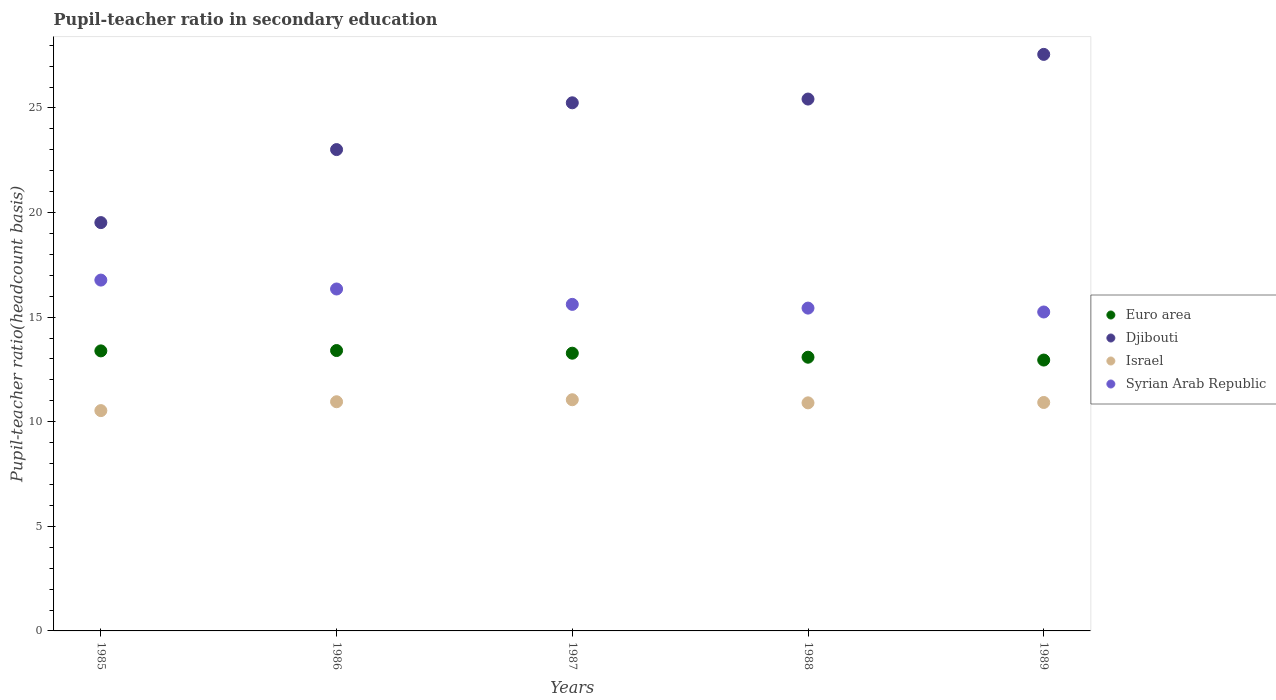How many different coloured dotlines are there?
Your answer should be very brief. 4. What is the pupil-teacher ratio in secondary education in Israel in 1988?
Your answer should be compact. 10.9. Across all years, what is the maximum pupil-teacher ratio in secondary education in Djibouti?
Ensure brevity in your answer.  27.56. Across all years, what is the minimum pupil-teacher ratio in secondary education in Syrian Arab Republic?
Offer a terse response. 15.25. In which year was the pupil-teacher ratio in secondary education in Djibouti maximum?
Your response must be concise. 1989. What is the total pupil-teacher ratio in secondary education in Israel in the graph?
Offer a very short reply. 54.36. What is the difference between the pupil-teacher ratio in secondary education in Israel in 1986 and that in 1989?
Offer a terse response. 0.03. What is the difference between the pupil-teacher ratio in secondary education in Syrian Arab Republic in 1988 and the pupil-teacher ratio in secondary education in Euro area in 1989?
Provide a succinct answer. 2.48. What is the average pupil-teacher ratio in secondary education in Euro area per year?
Keep it short and to the point. 13.22. In the year 1987, what is the difference between the pupil-teacher ratio in secondary education in Israel and pupil-teacher ratio in secondary education in Euro area?
Provide a short and direct response. -2.22. In how many years, is the pupil-teacher ratio in secondary education in Euro area greater than 20?
Give a very brief answer. 0. What is the ratio of the pupil-teacher ratio in secondary education in Israel in 1985 to that in 1988?
Your response must be concise. 0.97. What is the difference between the highest and the second highest pupil-teacher ratio in secondary education in Israel?
Your answer should be compact. 0.1. What is the difference between the highest and the lowest pupil-teacher ratio in secondary education in Djibouti?
Make the answer very short. 8.04. Is the sum of the pupil-teacher ratio in secondary education in Djibouti in 1985 and 1988 greater than the maximum pupil-teacher ratio in secondary education in Israel across all years?
Provide a short and direct response. Yes. Is it the case that in every year, the sum of the pupil-teacher ratio in secondary education in Israel and pupil-teacher ratio in secondary education in Syrian Arab Republic  is greater than the sum of pupil-teacher ratio in secondary education in Euro area and pupil-teacher ratio in secondary education in Djibouti?
Provide a succinct answer. No. Is it the case that in every year, the sum of the pupil-teacher ratio in secondary education in Euro area and pupil-teacher ratio in secondary education in Djibouti  is greater than the pupil-teacher ratio in secondary education in Syrian Arab Republic?
Keep it short and to the point. Yes. Does the pupil-teacher ratio in secondary education in Djibouti monotonically increase over the years?
Provide a short and direct response. Yes. Is the pupil-teacher ratio in secondary education in Syrian Arab Republic strictly greater than the pupil-teacher ratio in secondary education in Euro area over the years?
Give a very brief answer. Yes. Is the pupil-teacher ratio in secondary education in Djibouti strictly less than the pupil-teacher ratio in secondary education in Euro area over the years?
Give a very brief answer. No. How many years are there in the graph?
Ensure brevity in your answer.  5. Are the values on the major ticks of Y-axis written in scientific E-notation?
Keep it short and to the point. No. Does the graph contain any zero values?
Your answer should be very brief. No. Does the graph contain grids?
Make the answer very short. No. Where does the legend appear in the graph?
Offer a terse response. Center right. How many legend labels are there?
Give a very brief answer. 4. What is the title of the graph?
Your answer should be compact. Pupil-teacher ratio in secondary education. What is the label or title of the X-axis?
Your answer should be very brief. Years. What is the label or title of the Y-axis?
Your response must be concise. Pupil-teacher ratio(headcount basis). What is the Pupil-teacher ratio(headcount basis) in Euro area in 1985?
Offer a very short reply. 13.39. What is the Pupil-teacher ratio(headcount basis) of Djibouti in 1985?
Offer a very short reply. 19.52. What is the Pupil-teacher ratio(headcount basis) of Israel in 1985?
Provide a succinct answer. 10.53. What is the Pupil-teacher ratio(headcount basis) in Syrian Arab Republic in 1985?
Your answer should be compact. 16.77. What is the Pupil-teacher ratio(headcount basis) of Euro area in 1986?
Ensure brevity in your answer.  13.4. What is the Pupil-teacher ratio(headcount basis) in Djibouti in 1986?
Offer a terse response. 23.01. What is the Pupil-teacher ratio(headcount basis) in Israel in 1986?
Offer a very short reply. 10.96. What is the Pupil-teacher ratio(headcount basis) of Syrian Arab Republic in 1986?
Your answer should be very brief. 16.35. What is the Pupil-teacher ratio(headcount basis) of Euro area in 1987?
Provide a succinct answer. 13.28. What is the Pupil-teacher ratio(headcount basis) of Djibouti in 1987?
Make the answer very short. 25.25. What is the Pupil-teacher ratio(headcount basis) in Israel in 1987?
Keep it short and to the point. 11.05. What is the Pupil-teacher ratio(headcount basis) in Syrian Arab Republic in 1987?
Offer a very short reply. 15.61. What is the Pupil-teacher ratio(headcount basis) of Euro area in 1988?
Your answer should be compact. 13.08. What is the Pupil-teacher ratio(headcount basis) of Djibouti in 1988?
Keep it short and to the point. 25.43. What is the Pupil-teacher ratio(headcount basis) of Israel in 1988?
Offer a terse response. 10.9. What is the Pupil-teacher ratio(headcount basis) of Syrian Arab Republic in 1988?
Make the answer very short. 15.43. What is the Pupil-teacher ratio(headcount basis) of Euro area in 1989?
Offer a very short reply. 12.95. What is the Pupil-teacher ratio(headcount basis) in Djibouti in 1989?
Offer a terse response. 27.56. What is the Pupil-teacher ratio(headcount basis) of Israel in 1989?
Provide a short and direct response. 10.92. What is the Pupil-teacher ratio(headcount basis) of Syrian Arab Republic in 1989?
Offer a terse response. 15.25. Across all years, what is the maximum Pupil-teacher ratio(headcount basis) in Euro area?
Make the answer very short. 13.4. Across all years, what is the maximum Pupil-teacher ratio(headcount basis) of Djibouti?
Provide a short and direct response. 27.56. Across all years, what is the maximum Pupil-teacher ratio(headcount basis) of Israel?
Your answer should be very brief. 11.05. Across all years, what is the maximum Pupil-teacher ratio(headcount basis) of Syrian Arab Republic?
Make the answer very short. 16.77. Across all years, what is the minimum Pupil-teacher ratio(headcount basis) of Euro area?
Offer a very short reply. 12.95. Across all years, what is the minimum Pupil-teacher ratio(headcount basis) in Djibouti?
Offer a terse response. 19.52. Across all years, what is the minimum Pupil-teacher ratio(headcount basis) of Israel?
Give a very brief answer. 10.53. Across all years, what is the minimum Pupil-teacher ratio(headcount basis) in Syrian Arab Republic?
Ensure brevity in your answer.  15.25. What is the total Pupil-teacher ratio(headcount basis) of Euro area in the graph?
Your response must be concise. 66.1. What is the total Pupil-teacher ratio(headcount basis) of Djibouti in the graph?
Your answer should be compact. 120.76. What is the total Pupil-teacher ratio(headcount basis) in Israel in the graph?
Your answer should be very brief. 54.36. What is the total Pupil-teacher ratio(headcount basis) in Syrian Arab Republic in the graph?
Your answer should be compact. 79.4. What is the difference between the Pupil-teacher ratio(headcount basis) of Euro area in 1985 and that in 1986?
Ensure brevity in your answer.  -0.02. What is the difference between the Pupil-teacher ratio(headcount basis) in Djibouti in 1985 and that in 1986?
Provide a succinct answer. -3.49. What is the difference between the Pupil-teacher ratio(headcount basis) in Israel in 1985 and that in 1986?
Offer a terse response. -0.42. What is the difference between the Pupil-teacher ratio(headcount basis) in Syrian Arab Republic in 1985 and that in 1986?
Provide a succinct answer. 0.43. What is the difference between the Pupil-teacher ratio(headcount basis) in Euro area in 1985 and that in 1987?
Your answer should be very brief. 0.11. What is the difference between the Pupil-teacher ratio(headcount basis) in Djibouti in 1985 and that in 1987?
Make the answer very short. -5.73. What is the difference between the Pupil-teacher ratio(headcount basis) in Israel in 1985 and that in 1987?
Ensure brevity in your answer.  -0.52. What is the difference between the Pupil-teacher ratio(headcount basis) of Syrian Arab Republic in 1985 and that in 1987?
Give a very brief answer. 1.16. What is the difference between the Pupil-teacher ratio(headcount basis) in Euro area in 1985 and that in 1988?
Offer a terse response. 0.3. What is the difference between the Pupil-teacher ratio(headcount basis) in Djibouti in 1985 and that in 1988?
Make the answer very short. -5.91. What is the difference between the Pupil-teacher ratio(headcount basis) of Israel in 1985 and that in 1988?
Your response must be concise. -0.37. What is the difference between the Pupil-teacher ratio(headcount basis) in Syrian Arab Republic in 1985 and that in 1988?
Ensure brevity in your answer.  1.34. What is the difference between the Pupil-teacher ratio(headcount basis) in Euro area in 1985 and that in 1989?
Make the answer very short. 0.44. What is the difference between the Pupil-teacher ratio(headcount basis) of Djibouti in 1985 and that in 1989?
Your answer should be compact. -8.04. What is the difference between the Pupil-teacher ratio(headcount basis) in Israel in 1985 and that in 1989?
Provide a succinct answer. -0.39. What is the difference between the Pupil-teacher ratio(headcount basis) of Syrian Arab Republic in 1985 and that in 1989?
Provide a succinct answer. 1.53. What is the difference between the Pupil-teacher ratio(headcount basis) in Euro area in 1986 and that in 1987?
Give a very brief answer. 0.13. What is the difference between the Pupil-teacher ratio(headcount basis) of Djibouti in 1986 and that in 1987?
Give a very brief answer. -2.24. What is the difference between the Pupil-teacher ratio(headcount basis) in Israel in 1986 and that in 1987?
Offer a very short reply. -0.1. What is the difference between the Pupil-teacher ratio(headcount basis) in Syrian Arab Republic in 1986 and that in 1987?
Ensure brevity in your answer.  0.74. What is the difference between the Pupil-teacher ratio(headcount basis) of Euro area in 1986 and that in 1988?
Give a very brief answer. 0.32. What is the difference between the Pupil-teacher ratio(headcount basis) in Djibouti in 1986 and that in 1988?
Provide a succinct answer. -2.42. What is the difference between the Pupil-teacher ratio(headcount basis) of Israel in 1986 and that in 1988?
Provide a succinct answer. 0.05. What is the difference between the Pupil-teacher ratio(headcount basis) of Syrian Arab Republic in 1986 and that in 1988?
Provide a succinct answer. 0.91. What is the difference between the Pupil-teacher ratio(headcount basis) in Euro area in 1986 and that in 1989?
Your answer should be very brief. 0.45. What is the difference between the Pupil-teacher ratio(headcount basis) in Djibouti in 1986 and that in 1989?
Offer a terse response. -4.55. What is the difference between the Pupil-teacher ratio(headcount basis) of Israel in 1986 and that in 1989?
Make the answer very short. 0.03. What is the difference between the Pupil-teacher ratio(headcount basis) of Syrian Arab Republic in 1986 and that in 1989?
Ensure brevity in your answer.  1.1. What is the difference between the Pupil-teacher ratio(headcount basis) of Euro area in 1987 and that in 1988?
Offer a very short reply. 0.19. What is the difference between the Pupil-teacher ratio(headcount basis) of Djibouti in 1987 and that in 1988?
Give a very brief answer. -0.18. What is the difference between the Pupil-teacher ratio(headcount basis) in Israel in 1987 and that in 1988?
Your answer should be compact. 0.15. What is the difference between the Pupil-teacher ratio(headcount basis) of Syrian Arab Republic in 1987 and that in 1988?
Your response must be concise. 0.18. What is the difference between the Pupil-teacher ratio(headcount basis) in Euro area in 1987 and that in 1989?
Offer a very short reply. 0.33. What is the difference between the Pupil-teacher ratio(headcount basis) of Djibouti in 1987 and that in 1989?
Provide a succinct answer. -2.31. What is the difference between the Pupil-teacher ratio(headcount basis) in Israel in 1987 and that in 1989?
Your answer should be very brief. 0.13. What is the difference between the Pupil-teacher ratio(headcount basis) in Syrian Arab Republic in 1987 and that in 1989?
Your response must be concise. 0.36. What is the difference between the Pupil-teacher ratio(headcount basis) of Euro area in 1988 and that in 1989?
Give a very brief answer. 0.14. What is the difference between the Pupil-teacher ratio(headcount basis) of Djibouti in 1988 and that in 1989?
Give a very brief answer. -2.14. What is the difference between the Pupil-teacher ratio(headcount basis) of Israel in 1988 and that in 1989?
Your response must be concise. -0.02. What is the difference between the Pupil-teacher ratio(headcount basis) of Syrian Arab Republic in 1988 and that in 1989?
Provide a succinct answer. 0.19. What is the difference between the Pupil-teacher ratio(headcount basis) in Euro area in 1985 and the Pupil-teacher ratio(headcount basis) in Djibouti in 1986?
Your answer should be very brief. -9.62. What is the difference between the Pupil-teacher ratio(headcount basis) in Euro area in 1985 and the Pupil-teacher ratio(headcount basis) in Israel in 1986?
Your response must be concise. 2.43. What is the difference between the Pupil-teacher ratio(headcount basis) of Euro area in 1985 and the Pupil-teacher ratio(headcount basis) of Syrian Arab Republic in 1986?
Make the answer very short. -2.96. What is the difference between the Pupil-teacher ratio(headcount basis) of Djibouti in 1985 and the Pupil-teacher ratio(headcount basis) of Israel in 1986?
Your answer should be compact. 8.56. What is the difference between the Pupil-teacher ratio(headcount basis) of Djibouti in 1985 and the Pupil-teacher ratio(headcount basis) of Syrian Arab Republic in 1986?
Give a very brief answer. 3.17. What is the difference between the Pupil-teacher ratio(headcount basis) in Israel in 1985 and the Pupil-teacher ratio(headcount basis) in Syrian Arab Republic in 1986?
Provide a succinct answer. -5.81. What is the difference between the Pupil-teacher ratio(headcount basis) in Euro area in 1985 and the Pupil-teacher ratio(headcount basis) in Djibouti in 1987?
Provide a succinct answer. -11.86. What is the difference between the Pupil-teacher ratio(headcount basis) of Euro area in 1985 and the Pupil-teacher ratio(headcount basis) of Israel in 1987?
Provide a short and direct response. 2.34. What is the difference between the Pupil-teacher ratio(headcount basis) in Euro area in 1985 and the Pupil-teacher ratio(headcount basis) in Syrian Arab Republic in 1987?
Give a very brief answer. -2.22. What is the difference between the Pupil-teacher ratio(headcount basis) in Djibouti in 1985 and the Pupil-teacher ratio(headcount basis) in Israel in 1987?
Provide a succinct answer. 8.47. What is the difference between the Pupil-teacher ratio(headcount basis) of Djibouti in 1985 and the Pupil-teacher ratio(headcount basis) of Syrian Arab Republic in 1987?
Keep it short and to the point. 3.91. What is the difference between the Pupil-teacher ratio(headcount basis) of Israel in 1985 and the Pupil-teacher ratio(headcount basis) of Syrian Arab Republic in 1987?
Your answer should be compact. -5.08. What is the difference between the Pupil-teacher ratio(headcount basis) of Euro area in 1985 and the Pupil-teacher ratio(headcount basis) of Djibouti in 1988?
Provide a short and direct response. -12.04. What is the difference between the Pupil-teacher ratio(headcount basis) of Euro area in 1985 and the Pupil-teacher ratio(headcount basis) of Israel in 1988?
Make the answer very short. 2.48. What is the difference between the Pupil-teacher ratio(headcount basis) in Euro area in 1985 and the Pupil-teacher ratio(headcount basis) in Syrian Arab Republic in 1988?
Give a very brief answer. -2.04. What is the difference between the Pupil-teacher ratio(headcount basis) of Djibouti in 1985 and the Pupil-teacher ratio(headcount basis) of Israel in 1988?
Your response must be concise. 8.62. What is the difference between the Pupil-teacher ratio(headcount basis) in Djibouti in 1985 and the Pupil-teacher ratio(headcount basis) in Syrian Arab Republic in 1988?
Your response must be concise. 4.09. What is the difference between the Pupil-teacher ratio(headcount basis) of Israel in 1985 and the Pupil-teacher ratio(headcount basis) of Syrian Arab Republic in 1988?
Offer a terse response. -4.9. What is the difference between the Pupil-teacher ratio(headcount basis) of Euro area in 1985 and the Pupil-teacher ratio(headcount basis) of Djibouti in 1989?
Provide a short and direct response. -14.17. What is the difference between the Pupil-teacher ratio(headcount basis) in Euro area in 1985 and the Pupil-teacher ratio(headcount basis) in Israel in 1989?
Provide a succinct answer. 2.47. What is the difference between the Pupil-teacher ratio(headcount basis) of Euro area in 1985 and the Pupil-teacher ratio(headcount basis) of Syrian Arab Republic in 1989?
Offer a very short reply. -1.86. What is the difference between the Pupil-teacher ratio(headcount basis) in Djibouti in 1985 and the Pupil-teacher ratio(headcount basis) in Israel in 1989?
Make the answer very short. 8.6. What is the difference between the Pupil-teacher ratio(headcount basis) of Djibouti in 1985 and the Pupil-teacher ratio(headcount basis) of Syrian Arab Republic in 1989?
Provide a short and direct response. 4.27. What is the difference between the Pupil-teacher ratio(headcount basis) in Israel in 1985 and the Pupil-teacher ratio(headcount basis) in Syrian Arab Republic in 1989?
Give a very brief answer. -4.71. What is the difference between the Pupil-teacher ratio(headcount basis) of Euro area in 1986 and the Pupil-teacher ratio(headcount basis) of Djibouti in 1987?
Offer a very short reply. -11.84. What is the difference between the Pupil-teacher ratio(headcount basis) in Euro area in 1986 and the Pupil-teacher ratio(headcount basis) in Israel in 1987?
Offer a terse response. 2.35. What is the difference between the Pupil-teacher ratio(headcount basis) of Euro area in 1986 and the Pupil-teacher ratio(headcount basis) of Syrian Arab Republic in 1987?
Offer a very short reply. -2.21. What is the difference between the Pupil-teacher ratio(headcount basis) of Djibouti in 1986 and the Pupil-teacher ratio(headcount basis) of Israel in 1987?
Offer a very short reply. 11.96. What is the difference between the Pupil-teacher ratio(headcount basis) in Djibouti in 1986 and the Pupil-teacher ratio(headcount basis) in Syrian Arab Republic in 1987?
Keep it short and to the point. 7.4. What is the difference between the Pupil-teacher ratio(headcount basis) in Israel in 1986 and the Pupil-teacher ratio(headcount basis) in Syrian Arab Republic in 1987?
Keep it short and to the point. -4.66. What is the difference between the Pupil-teacher ratio(headcount basis) in Euro area in 1986 and the Pupil-teacher ratio(headcount basis) in Djibouti in 1988?
Your answer should be compact. -12.02. What is the difference between the Pupil-teacher ratio(headcount basis) of Euro area in 1986 and the Pupil-teacher ratio(headcount basis) of Israel in 1988?
Make the answer very short. 2.5. What is the difference between the Pupil-teacher ratio(headcount basis) in Euro area in 1986 and the Pupil-teacher ratio(headcount basis) in Syrian Arab Republic in 1988?
Give a very brief answer. -2.03. What is the difference between the Pupil-teacher ratio(headcount basis) of Djibouti in 1986 and the Pupil-teacher ratio(headcount basis) of Israel in 1988?
Give a very brief answer. 12.11. What is the difference between the Pupil-teacher ratio(headcount basis) of Djibouti in 1986 and the Pupil-teacher ratio(headcount basis) of Syrian Arab Republic in 1988?
Keep it short and to the point. 7.58. What is the difference between the Pupil-teacher ratio(headcount basis) of Israel in 1986 and the Pupil-teacher ratio(headcount basis) of Syrian Arab Republic in 1988?
Your answer should be compact. -4.48. What is the difference between the Pupil-teacher ratio(headcount basis) of Euro area in 1986 and the Pupil-teacher ratio(headcount basis) of Djibouti in 1989?
Offer a very short reply. -14.16. What is the difference between the Pupil-teacher ratio(headcount basis) of Euro area in 1986 and the Pupil-teacher ratio(headcount basis) of Israel in 1989?
Ensure brevity in your answer.  2.48. What is the difference between the Pupil-teacher ratio(headcount basis) in Euro area in 1986 and the Pupil-teacher ratio(headcount basis) in Syrian Arab Republic in 1989?
Offer a very short reply. -1.84. What is the difference between the Pupil-teacher ratio(headcount basis) in Djibouti in 1986 and the Pupil-teacher ratio(headcount basis) in Israel in 1989?
Your response must be concise. 12.09. What is the difference between the Pupil-teacher ratio(headcount basis) in Djibouti in 1986 and the Pupil-teacher ratio(headcount basis) in Syrian Arab Republic in 1989?
Your answer should be very brief. 7.76. What is the difference between the Pupil-teacher ratio(headcount basis) of Israel in 1986 and the Pupil-teacher ratio(headcount basis) of Syrian Arab Republic in 1989?
Offer a very short reply. -4.29. What is the difference between the Pupil-teacher ratio(headcount basis) of Euro area in 1987 and the Pupil-teacher ratio(headcount basis) of Djibouti in 1988?
Your answer should be very brief. -12.15. What is the difference between the Pupil-teacher ratio(headcount basis) of Euro area in 1987 and the Pupil-teacher ratio(headcount basis) of Israel in 1988?
Offer a very short reply. 2.37. What is the difference between the Pupil-teacher ratio(headcount basis) in Euro area in 1987 and the Pupil-teacher ratio(headcount basis) in Syrian Arab Republic in 1988?
Your answer should be compact. -2.16. What is the difference between the Pupil-teacher ratio(headcount basis) in Djibouti in 1987 and the Pupil-teacher ratio(headcount basis) in Israel in 1988?
Offer a terse response. 14.34. What is the difference between the Pupil-teacher ratio(headcount basis) in Djibouti in 1987 and the Pupil-teacher ratio(headcount basis) in Syrian Arab Republic in 1988?
Offer a very short reply. 9.81. What is the difference between the Pupil-teacher ratio(headcount basis) of Israel in 1987 and the Pupil-teacher ratio(headcount basis) of Syrian Arab Republic in 1988?
Provide a succinct answer. -4.38. What is the difference between the Pupil-teacher ratio(headcount basis) of Euro area in 1987 and the Pupil-teacher ratio(headcount basis) of Djibouti in 1989?
Your response must be concise. -14.28. What is the difference between the Pupil-teacher ratio(headcount basis) of Euro area in 1987 and the Pupil-teacher ratio(headcount basis) of Israel in 1989?
Give a very brief answer. 2.36. What is the difference between the Pupil-teacher ratio(headcount basis) of Euro area in 1987 and the Pupil-teacher ratio(headcount basis) of Syrian Arab Republic in 1989?
Provide a short and direct response. -1.97. What is the difference between the Pupil-teacher ratio(headcount basis) of Djibouti in 1987 and the Pupil-teacher ratio(headcount basis) of Israel in 1989?
Offer a very short reply. 14.33. What is the difference between the Pupil-teacher ratio(headcount basis) in Djibouti in 1987 and the Pupil-teacher ratio(headcount basis) in Syrian Arab Republic in 1989?
Keep it short and to the point. 10. What is the difference between the Pupil-teacher ratio(headcount basis) of Israel in 1987 and the Pupil-teacher ratio(headcount basis) of Syrian Arab Republic in 1989?
Offer a terse response. -4.19. What is the difference between the Pupil-teacher ratio(headcount basis) in Euro area in 1988 and the Pupil-teacher ratio(headcount basis) in Djibouti in 1989?
Give a very brief answer. -14.48. What is the difference between the Pupil-teacher ratio(headcount basis) of Euro area in 1988 and the Pupil-teacher ratio(headcount basis) of Israel in 1989?
Your response must be concise. 2.16. What is the difference between the Pupil-teacher ratio(headcount basis) of Euro area in 1988 and the Pupil-teacher ratio(headcount basis) of Syrian Arab Republic in 1989?
Provide a succinct answer. -2.16. What is the difference between the Pupil-teacher ratio(headcount basis) in Djibouti in 1988 and the Pupil-teacher ratio(headcount basis) in Israel in 1989?
Offer a very short reply. 14.5. What is the difference between the Pupil-teacher ratio(headcount basis) in Djibouti in 1988 and the Pupil-teacher ratio(headcount basis) in Syrian Arab Republic in 1989?
Your answer should be compact. 10.18. What is the difference between the Pupil-teacher ratio(headcount basis) in Israel in 1988 and the Pupil-teacher ratio(headcount basis) in Syrian Arab Republic in 1989?
Your answer should be compact. -4.34. What is the average Pupil-teacher ratio(headcount basis) in Euro area per year?
Give a very brief answer. 13.22. What is the average Pupil-teacher ratio(headcount basis) of Djibouti per year?
Your answer should be compact. 24.15. What is the average Pupil-teacher ratio(headcount basis) of Israel per year?
Provide a short and direct response. 10.87. What is the average Pupil-teacher ratio(headcount basis) of Syrian Arab Republic per year?
Provide a succinct answer. 15.88. In the year 1985, what is the difference between the Pupil-teacher ratio(headcount basis) in Euro area and Pupil-teacher ratio(headcount basis) in Djibouti?
Keep it short and to the point. -6.13. In the year 1985, what is the difference between the Pupil-teacher ratio(headcount basis) of Euro area and Pupil-teacher ratio(headcount basis) of Israel?
Offer a very short reply. 2.86. In the year 1985, what is the difference between the Pupil-teacher ratio(headcount basis) of Euro area and Pupil-teacher ratio(headcount basis) of Syrian Arab Republic?
Ensure brevity in your answer.  -3.38. In the year 1985, what is the difference between the Pupil-teacher ratio(headcount basis) in Djibouti and Pupil-teacher ratio(headcount basis) in Israel?
Give a very brief answer. 8.99. In the year 1985, what is the difference between the Pupil-teacher ratio(headcount basis) of Djibouti and Pupil-teacher ratio(headcount basis) of Syrian Arab Republic?
Keep it short and to the point. 2.75. In the year 1985, what is the difference between the Pupil-teacher ratio(headcount basis) of Israel and Pupil-teacher ratio(headcount basis) of Syrian Arab Republic?
Provide a succinct answer. -6.24. In the year 1986, what is the difference between the Pupil-teacher ratio(headcount basis) in Euro area and Pupil-teacher ratio(headcount basis) in Djibouti?
Your answer should be very brief. -9.61. In the year 1986, what is the difference between the Pupil-teacher ratio(headcount basis) of Euro area and Pupil-teacher ratio(headcount basis) of Israel?
Your response must be concise. 2.45. In the year 1986, what is the difference between the Pupil-teacher ratio(headcount basis) of Euro area and Pupil-teacher ratio(headcount basis) of Syrian Arab Republic?
Make the answer very short. -2.94. In the year 1986, what is the difference between the Pupil-teacher ratio(headcount basis) in Djibouti and Pupil-teacher ratio(headcount basis) in Israel?
Offer a very short reply. 12.05. In the year 1986, what is the difference between the Pupil-teacher ratio(headcount basis) in Djibouti and Pupil-teacher ratio(headcount basis) in Syrian Arab Republic?
Your response must be concise. 6.66. In the year 1986, what is the difference between the Pupil-teacher ratio(headcount basis) of Israel and Pupil-teacher ratio(headcount basis) of Syrian Arab Republic?
Offer a very short reply. -5.39. In the year 1987, what is the difference between the Pupil-teacher ratio(headcount basis) in Euro area and Pupil-teacher ratio(headcount basis) in Djibouti?
Provide a succinct answer. -11.97. In the year 1987, what is the difference between the Pupil-teacher ratio(headcount basis) in Euro area and Pupil-teacher ratio(headcount basis) in Israel?
Your answer should be compact. 2.22. In the year 1987, what is the difference between the Pupil-teacher ratio(headcount basis) of Euro area and Pupil-teacher ratio(headcount basis) of Syrian Arab Republic?
Give a very brief answer. -2.33. In the year 1987, what is the difference between the Pupil-teacher ratio(headcount basis) in Djibouti and Pupil-teacher ratio(headcount basis) in Israel?
Offer a very short reply. 14.19. In the year 1987, what is the difference between the Pupil-teacher ratio(headcount basis) of Djibouti and Pupil-teacher ratio(headcount basis) of Syrian Arab Republic?
Keep it short and to the point. 9.64. In the year 1987, what is the difference between the Pupil-teacher ratio(headcount basis) in Israel and Pupil-teacher ratio(headcount basis) in Syrian Arab Republic?
Ensure brevity in your answer.  -4.56. In the year 1988, what is the difference between the Pupil-teacher ratio(headcount basis) of Euro area and Pupil-teacher ratio(headcount basis) of Djibouti?
Offer a terse response. -12.34. In the year 1988, what is the difference between the Pupil-teacher ratio(headcount basis) of Euro area and Pupil-teacher ratio(headcount basis) of Israel?
Your answer should be very brief. 2.18. In the year 1988, what is the difference between the Pupil-teacher ratio(headcount basis) of Euro area and Pupil-teacher ratio(headcount basis) of Syrian Arab Republic?
Your response must be concise. -2.35. In the year 1988, what is the difference between the Pupil-teacher ratio(headcount basis) in Djibouti and Pupil-teacher ratio(headcount basis) in Israel?
Provide a short and direct response. 14.52. In the year 1988, what is the difference between the Pupil-teacher ratio(headcount basis) of Djibouti and Pupil-teacher ratio(headcount basis) of Syrian Arab Republic?
Make the answer very short. 9.99. In the year 1988, what is the difference between the Pupil-teacher ratio(headcount basis) in Israel and Pupil-teacher ratio(headcount basis) in Syrian Arab Republic?
Provide a short and direct response. -4.53. In the year 1989, what is the difference between the Pupil-teacher ratio(headcount basis) in Euro area and Pupil-teacher ratio(headcount basis) in Djibouti?
Provide a short and direct response. -14.61. In the year 1989, what is the difference between the Pupil-teacher ratio(headcount basis) of Euro area and Pupil-teacher ratio(headcount basis) of Israel?
Provide a succinct answer. 2.03. In the year 1989, what is the difference between the Pupil-teacher ratio(headcount basis) of Euro area and Pupil-teacher ratio(headcount basis) of Syrian Arab Republic?
Give a very brief answer. -2.3. In the year 1989, what is the difference between the Pupil-teacher ratio(headcount basis) in Djibouti and Pupil-teacher ratio(headcount basis) in Israel?
Give a very brief answer. 16.64. In the year 1989, what is the difference between the Pupil-teacher ratio(headcount basis) of Djibouti and Pupil-teacher ratio(headcount basis) of Syrian Arab Republic?
Make the answer very short. 12.31. In the year 1989, what is the difference between the Pupil-teacher ratio(headcount basis) in Israel and Pupil-teacher ratio(headcount basis) in Syrian Arab Republic?
Keep it short and to the point. -4.33. What is the ratio of the Pupil-teacher ratio(headcount basis) of Djibouti in 1985 to that in 1986?
Give a very brief answer. 0.85. What is the ratio of the Pupil-teacher ratio(headcount basis) in Israel in 1985 to that in 1986?
Provide a succinct answer. 0.96. What is the ratio of the Pupil-teacher ratio(headcount basis) in Syrian Arab Republic in 1985 to that in 1986?
Your response must be concise. 1.03. What is the ratio of the Pupil-teacher ratio(headcount basis) in Euro area in 1985 to that in 1987?
Ensure brevity in your answer.  1.01. What is the ratio of the Pupil-teacher ratio(headcount basis) in Djibouti in 1985 to that in 1987?
Your answer should be very brief. 0.77. What is the ratio of the Pupil-teacher ratio(headcount basis) in Israel in 1985 to that in 1987?
Give a very brief answer. 0.95. What is the ratio of the Pupil-teacher ratio(headcount basis) in Syrian Arab Republic in 1985 to that in 1987?
Offer a very short reply. 1.07. What is the ratio of the Pupil-teacher ratio(headcount basis) of Euro area in 1985 to that in 1988?
Provide a short and direct response. 1.02. What is the ratio of the Pupil-teacher ratio(headcount basis) in Djibouti in 1985 to that in 1988?
Offer a terse response. 0.77. What is the ratio of the Pupil-teacher ratio(headcount basis) in Syrian Arab Republic in 1985 to that in 1988?
Give a very brief answer. 1.09. What is the ratio of the Pupil-teacher ratio(headcount basis) in Euro area in 1985 to that in 1989?
Provide a succinct answer. 1.03. What is the ratio of the Pupil-teacher ratio(headcount basis) of Djibouti in 1985 to that in 1989?
Give a very brief answer. 0.71. What is the ratio of the Pupil-teacher ratio(headcount basis) of Israel in 1985 to that in 1989?
Ensure brevity in your answer.  0.96. What is the ratio of the Pupil-teacher ratio(headcount basis) of Syrian Arab Republic in 1985 to that in 1989?
Keep it short and to the point. 1.1. What is the ratio of the Pupil-teacher ratio(headcount basis) in Euro area in 1986 to that in 1987?
Offer a very short reply. 1.01. What is the ratio of the Pupil-teacher ratio(headcount basis) of Djibouti in 1986 to that in 1987?
Ensure brevity in your answer.  0.91. What is the ratio of the Pupil-teacher ratio(headcount basis) in Syrian Arab Republic in 1986 to that in 1987?
Keep it short and to the point. 1.05. What is the ratio of the Pupil-teacher ratio(headcount basis) of Euro area in 1986 to that in 1988?
Your answer should be very brief. 1.02. What is the ratio of the Pupil-teacher ratio(headcount basis) of Djibouti in 1986 to that in 1988?
Provide a short and direct response. 0.91. What is the ratio of the Pupil-teacher ratio(headcount basis) of Israel in 1986 to that in 1988?
Offer a terse response. 1. What is the ratio of the Pupil-teacher ratio(headcount basis) in Syrian Arab Republic in 1986 to that in 1988?
Ensure brevity in your answer.  1.06. What is the ratio of the Pupil-teacher ratio(headcount basis) of Euro area in 1986 to that in 1989?
Give a very brief answer. 1.04. What is the ratio of the Pupil-teacher ratio(headcount basis) in Djibouti in 1986 to that in 1989?
Your answer should be compact. 0.83. What is the ratio of the Pupil-teacher ratio(headcount basis) of Syrian Arab Republic in 1986 to that in 1989?
Your response must be concise. 1.07. What is the ratio of the Pupil-teacher ratio(headcount basis) of Euro area in 1987 to that in 1988?
Provide a succinct answer. 1.01. What is the ratio of the Pupil-teacher ratio(headcount basis) of Djibouti in 1987 to that in 1988?
Your answer should be very brief. 0.99. What is the ratio of the Pupil-teacher ratio(headcount basis) in Israel in 1987 to that in 1988?
Offer a terse response. 1.01. What is the ratio of the Pupil-teacher ratio(headcount basis) in Syrian Arab Republic in 1987 to that in 1988?
Keep it short and to the point. 1.01. What is the ratio of the Pupil-teacher ratio(headcount basis) of Euro area in 1987 to that in 1989?
Give a very brief answer. 1.03. What is the ratio of the Pupil-teacher ratio(headcount basis) in Djibouti in 1987 to that in 1989?
Make the answer very short. 0.92. What is the ratio of the Pupil-teacher ratio(headcount basis) in Syrian Arab Republic in 1987 to that in 1989?
Make the answer very short. 1.02. What is the ratio of the Pupil-teacher ratio(headcount basis) of Euro area in 1988 to that in 1989?
Provide a short and direct response. 1.01. What is the ratio of the Pupil-teacher ratio(headcount basis) in Djibouti in 1988 to that in 1989?
Offer a terse response. 0.92. What is the ratio of the Pupil-teacher ratio(headcount basis) in Israel in 1988 to that in 1989?
Provide a short and direct response. 1. What is the ratio of the Pupil-teacher ratio(headcount basis) of Syrian Arab Republic in 1988 to that in 1989?
Ensure brevity in your answer.  1.01. What is the difference between the highest and the second highest Pupil-teacher ratio(headcount basis) in Euro area?
Keep it short and to the point. 0.02. What is the difference between the highest and the second highest Pupil-teacher ratio(headcount basis) of Djibouti?
Make the answer very short. 2.14. What is the difference between the highest and the second highest Pupil-teacher ratio(headcount basis) of Israel?
Give a very brief answer. 0.1. What is the difference between the highest and the second highest Pupil-teacher ratio(headcount basis) of Syrian Arab Republic?
Offer a terse response. 0.43. What is the difference between the highest and the lowest Pupil-teacher ratio(headcount basis) in Euro area?
Offer a terse response. 0.45. What is the difference between the highest and the lowest Pupil-teacher ratio(headcount basis) of Djibouti?
Provide a short and direct response. 8.04. What is the difference between the highest and the lowest Pupil-teacher ratio(headcount basis) in Israel?
Your answer should be compact. 0.52. What is the difference between the highest and the lowest Pupil-teacher ratio(headcount basis) in Syrian Arab Republic?
Your answer should be very brief. 1.53. 